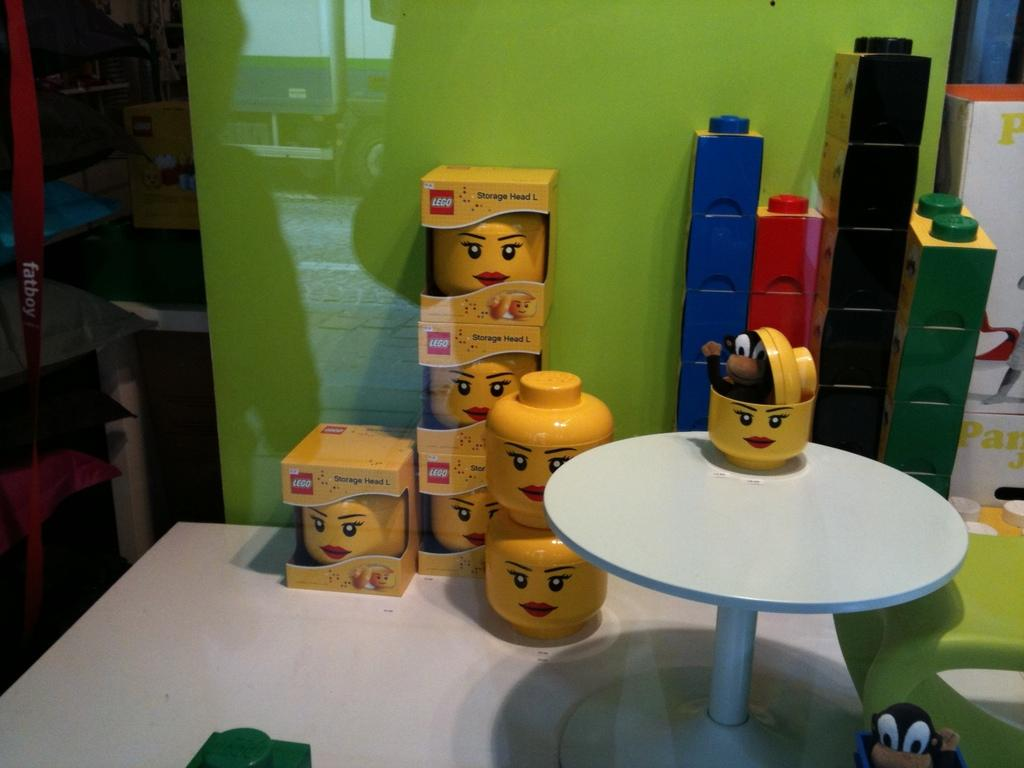What type of objects are contained within the boxes in the image? There are toys in the boxes in the image. What other objects can be seen in the image besides the boxes? There are blocks visible in the image. What type of containers are present in the background of the image? There are cardboard boxes in the background of the image. What is the material of the glass in the background of the image? The glass in the background of the image is made of glass. How many beads are present on the birthday cake in the image? There is no birthday cake or beads present in the image. 